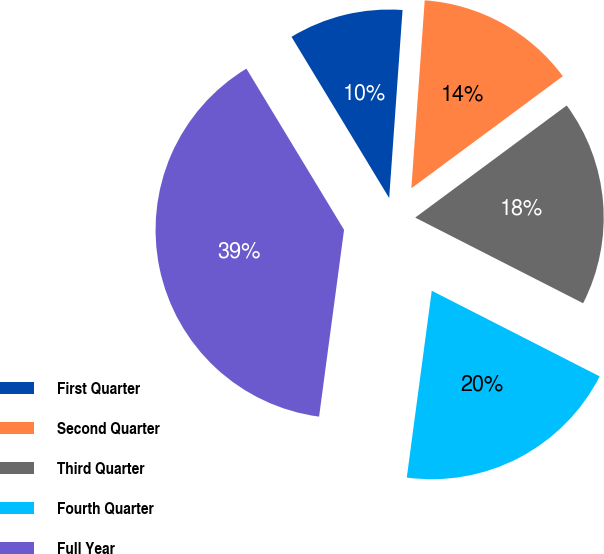Convert chart to OTSL. <chart><loc_0><loc_0><loc_500><loc_500><pie_chart><fcel>First Quarter<fcel>Second Quarter<fcel>Third Quarter<fcel>Fourth Quarter<fcel>Full Year<nl><fcel>9.8%<fcel>13.73%<fcel>17.65%<fcel>19.61%<fcel>39.22%<nl></chart> 